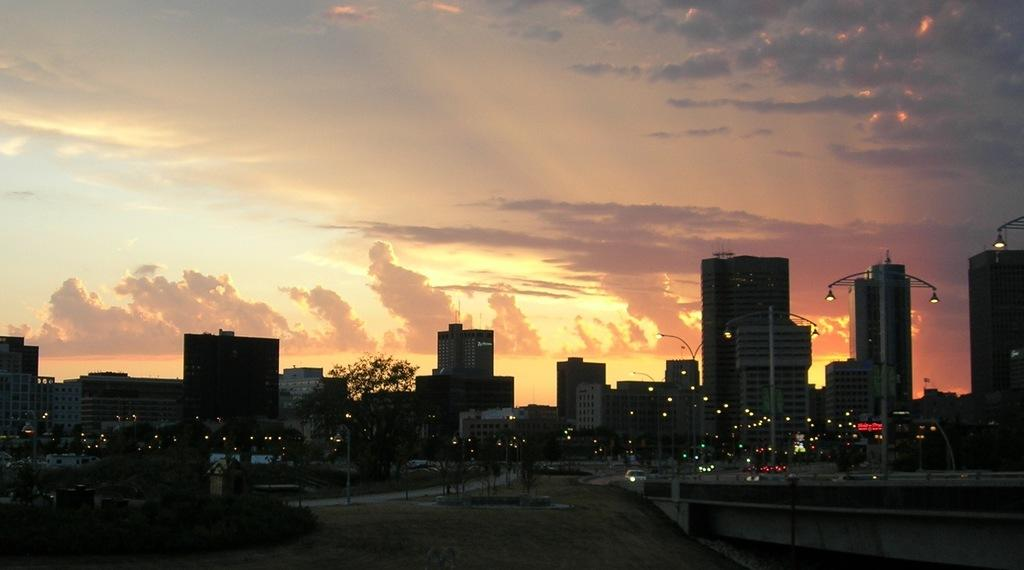What type of structures can be seen in the image? There are many buildings in the image. What other natural elements are present in the image? There are trees in the image. Are there any artificial light sources visible in the image? Yes, there are lights in the image. What is visible at the top of the image? The sky is visible at the top of the image. Can you tell me how many rings are on the finger of the person in the image? There is no person present in the image, and therefore no rings can be observed. What type of fuel is being used by the airplane in the image? There is no airplane present in the image, so it is not possible to determine what type of fuel might be used. 